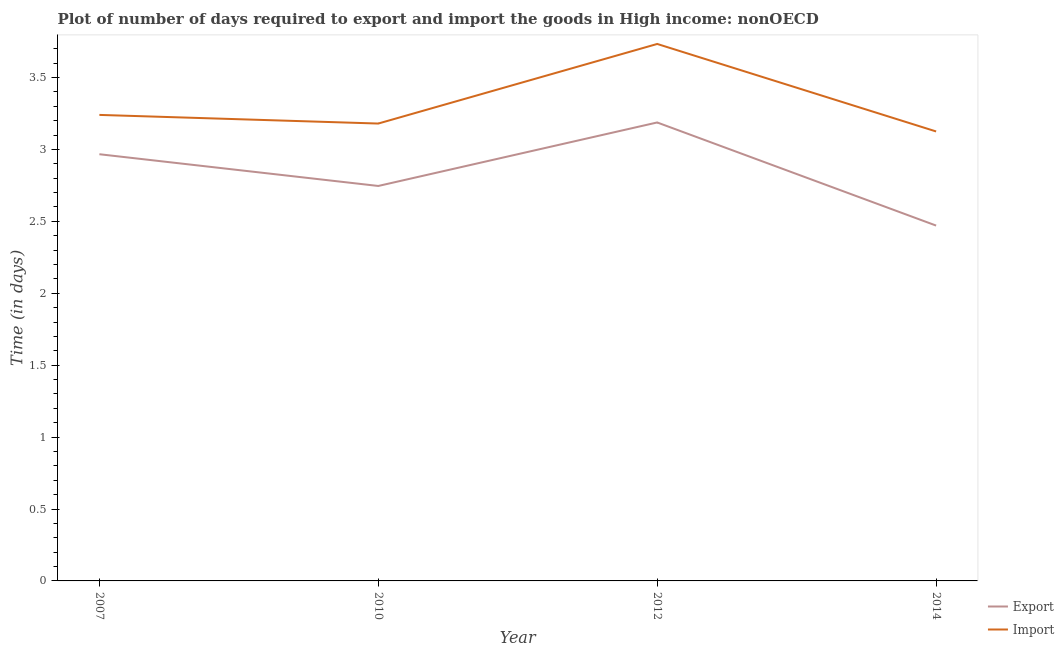How many different coloured lines are there?
Give a very brief answer. 2. Is the number of lines equal to the number of legend labels?
Offer a very short reply. Yes. What is the time required to import in 2007?
Provide a short and direct response. 3.24. Across all years, what is the maximum time required to export?
Ensure brevity in your answer.  3.19. Across all years, what is the minimum time required to export?
Give a very brief answer. 2.47. In which year was the time required to import maximum?
Your answer should be compact. 2012. In which year was the time required to export minimum?
Keep it short and to the point. 2014. What is the total time required to import in the graph?
Make the answer very short. 13.28. What is the difference between the time required to export in 2010 and that in 2014?
Give a very brief answer. 0.28. What is the difference between the time required to export in 2010 and the time required to import in 2007?
Your answer should be very brief. -0.49. What is the average time required to import per year?
Give a very brief answer. 3.32. In the year 2007, what is the difference between the time required to import and time required to export?
Make the answer very short. 0.27. In how many years, is the time required to export greater than 0.5 days?
Your response must be concise. 4. What is the ratio of the time required to export in 2007 to that in 2012?
Your answer should be very brief. 0.93. Is the time required to export in 2010 less than that in 2012?
Ensure brevity in your answer.  Yes. Is the difference between the time required to import in 2012 and 2014 greater than the difference between the time required to export in 2012 and 2014?
Make the answer very short. No. What is the difference between the highest and the second highest time required to import?
Keep it short and to the point. 0.49. What is the difference between the highest and the lowest time required to import?
Ensure brevity in your answer.  0.61. In how many years, is the time required to import greater than the average time required to import taken over all years?
Provide a short and direct response. 1. Is the sum of the time required to import in 2012 and 2014 greater than the maximum time required to export across all years?
Provide a succinct answer. Yes. Does the time required to export monotonically increase over the years?
Your answer should be compact. No. Is the time required to export strictly greater than the time required to import over the years?
Keep it short and to the point. No. How many lines are there?
Give a very brief answer. 2. What is the difference between two consecutive major ticks on the Y-axis?
Make the answer very short. 0.5. Are the values on the major ticks of Y-axis written in scientific E-notation?
Your response must be concise. No. Where does the legend appear in the graph?
Your answer should be very brief. Bottom right. What is the title of the graph?
Provide a short and direct response. Plot of number of days required to export and import the goods in High income: nonOECD. What is the label or title of the Y-axis?
Your answer should be compact. Time (in days). What is the Time (in days) in Export in 2007?
Your answer should be compact. 2.97. What is the Time (in days) of Import in 2007?
Provide a succinct answer. 3.24. What is the Time (in days) in Export in 2010?
Keep it short and to the point. 2.75. What is the Time (in days) of Import in 2010?
Provide a short and direct response. 3.18. What is the Time (in days) of Export in 2012?
Your answer should be very brief. 3.19. What is the Time (in days) in Import in 2012?
Your answer should be compact. 3.73. What is the Time (in days) in Export in 2014?
Your response must be concise. 2.47. What is the Time (in days) in Import in 2014?
Give a very brief answer. 3.12. Across all years, what is the maximum Time (in days) of Export?
Ensure brevity in your answer.  3.19. Across all years, what is the maximum Time (in days) in Import?
Your answer should be very brief. 3.73. Across all years, what is the minimum Time (in days) of Export?
Offer a very short reply. 2.47. Across all years, what is the minimum Time (in days) of Import?
Offer a very short reply. 3.12. What is the total Time (in days) of Export in the graph?
Your answer should be very brief. 11.37. What is the total Time (in days) of Import in the graph?
Your response must be concise. 13.28. What is the difference between the Time (in days) of Export in 2007 and that in 2010?
Offer a terse response. 0.22. What is the difference between the Time (in days) of Import in 2007 and that in 2010?
Make the answer very short. 0.06. What is the difference between the Time (in days) in Export in 2007 and that in 2012?
Provide a succinct answer. -0.22. What is the difference between the Time (in days) of Import in 2007 and that in 2012?
Provide a succinct answer. -0.49. What is the difference between the Time (in days) of Export in 2007 and that in 2014?
Provide a succinct answer. 0.5. What is the difference between the Time (in days) of Import in 2007 and that in 2014?
Give a very brief answer. 0.12. What is the difference between the Time (in days) in Export in 2010 and that in 2012?
Your response must be concise. -0.44. What is the difference between the Time (in days) of Import in 2010 and that in 2012?
Provide a succinct answer. -0.55. What is the difference between the Time (in days) of Export in 2010 and that in 2014?
Give a very brief answer. 0.28. What is the difference between the Time (in days) in Import in 2010 and that in 2014?
Provide a short and direct response. 0.06. What is the difference between the Time (in days) in Export in 2012 and that in 2014?
Your response must be concise. 0.72. What is the difference between the Time (in days) of Import in 2012 and that in 2014?
Give a very brief answer. 0.61. What is the difference between the Time (in days) of Export in 2007 and the Time (in days) of Import in 2010?
Keep it short and to the point. -0.21. What is the difference between the Time (in days) in Export in 2007 and the Time (in days) in Import in 2012?
Ensure brevity in your answer.  -0.77. What is the difference between the Time (in days) in Export in 2007 and the Time (in days) in Import in 2014?
Give a very brief answer. -0.16. What is the difference between the Time (in days) in Export in 2010 and the Time (in days) in Import in 2012?
Give a very brief answer. -0.99. What is the difference between the Time (in days) in Export in 2010 and the Time (in days) in Import in 2014?
Give a very brief answer. -0.38. What is the difference between the Time (in days) in Export in 2012 and the Time (in days) in Import in 2014?
Keep it short and to the point. 0.06. What is the average Time (in days) of Export per year?
Make the answer very short. 2.84. What is the average Time (in days) in Import per year?
Offer a very short reply. 3.32. In the year 2007, what is the difference between the Time (in days) in Export and Time (in days) in Import?
Keep it short and to the point. -0.27. In the year 2010, what is the difference between the Time (in days) in Export and Time (in days) in Import?
Give a very brief answer. -0.43. In the year 2012, what is the difference between the Time (in days) in Export and Time (in days) in Import?
Give a very brief answer. -0.55. In the year 2014, what is the difference between the Time (in days) in Export and Time (in days) in Import?
Provide a succinct answer. -0.65. What is the ratio of the Time (in days) in Export in 2007 to that in 2010?
Make the answer very short. 1.08. What is the ratio of the Time (in days) of Import in 2007 to that in 2010?
Offer a very short reply. 1.02. What is the ratio of the Time (in days) in Export in 2007 to that in 2012?
Make the answer very short. 0.93. What is the ratio of the Time (in days) in Import in 2007 to that in 2012?
Provide a short and direct response. 0.87. What is the ratio of the Time (in days) in Export in 2007 to that in 2014?
Give a very brief answer. 1.2. What is the ratio of the Time (in days) in Import in 2007 to that in 2014?
Your answer should be very brief. 1.04. What is the ratio of the Time (in days) in Export in 2010 to that in 2012?
Your response must be concise. 0.86. What is the ratio of the Time (in days) of Import in 2010 to that in 2012?
Your answer should be very brief. 0.85. What is the ratio of the Time (in days) of Export in 2010 to that in 2014?
Keep it short and to the point. 1.11. What is the ratio of the Time (in days) of Import in 2010 to that in 2014?
Provide a succinct answer. 1.02. What is the ratio of the Time (in days) in Export in 2012 to that in 2014?
Ensure brevity in your answer.  1.29. What is the ratio of the Time (in days) of Import in 2012 to that in 2014?
Your response must be concise. 1.19. What is the difference between the highest and the second highest Time (in days) in Export?
Provide a short and direct response. 0.22. What is the difference between the highest and the second highest Time (in days) of Import?
Provide a short and direct response. 0.49. What is the difference between the highest and the lowest Time (in days) of Export?
Keep it short and to the point. 0.72. What is the difference between the highest and the lowest Time (in days) of Import?
Keep it short and to the point. 0.61. 